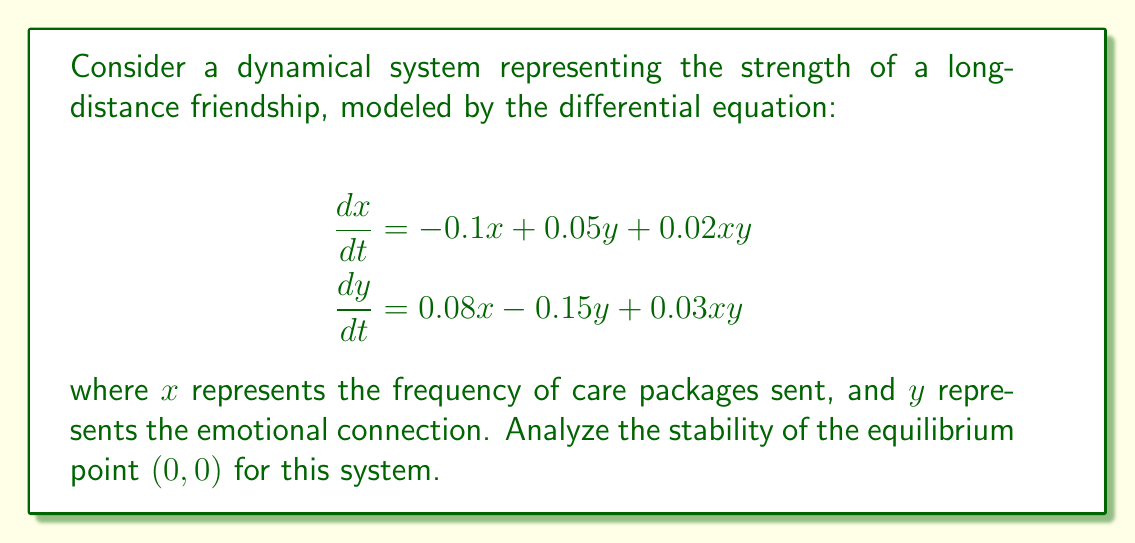Teach me how to tackle this problem. To analyze the stability of the equilibrium point $(0,0)$, we need to follow these steps:

1. Find the Jacobian matrix of the system:
   The Jacobian matrix $J$ is given by:
   $$J = \begin{bmatrix}
   \frac{\partial f_1}{\partial x} & \frac{\partial f_1}{\partial y} \\
   \frac{\partial f_2}{\partial x} & \frac{\partial f_2}{\partial y}
   \end{bmatrix}$$
   
   Where $f_1 = -0.1x + 0.05y + 0.02xy$ and $f_2 = 0.08x - 0.15y + 0.03xy$

2. Evaluate the Jacobian at the equilibrium point $(0,0)$:
   $$J_{(0,0)} = \begin{bmatrix}
   -0.1 & 0.05 \\
   0.08 & -0.15
   \end{bmatrix}$$

3. Calculate the eigenvalues of $J_{(0,0)}$:
   The characteristic equation is:
   $$\det(J_{(0,0)} - \lambda I) = 0$$
   $$\begin{vmatrix}
   -0.1 - \lambda & 0.05 \\
   0.08 & -0.15 - \lambda
   \end{vmatrix} = 0$$
   
   $$(-0.1 - \lambda)(-0.15 - \lambda) - 0.05 \cdot 0.08 = 0$$
   $$\lambda^2 + 0.25\lambda + 0.011 = 0$$

4. Solve the quadratic equation:
   Using the quadratic formula, we get:
   $$\lambda = \frac{-0.25 \pm \sqrt{0.25^2 - 4(0.011)}}{2}$$
   $$\lambda_1 \approx -0.2279$$
   $$\lambda_2 \approx -0.0221$$

5. Interpret the results:
   Both eigenvalues are real and negative. This indicates that the equilibrium point $(0,0)$ is asymptotically stable.
Answer: Asymptotically stable 